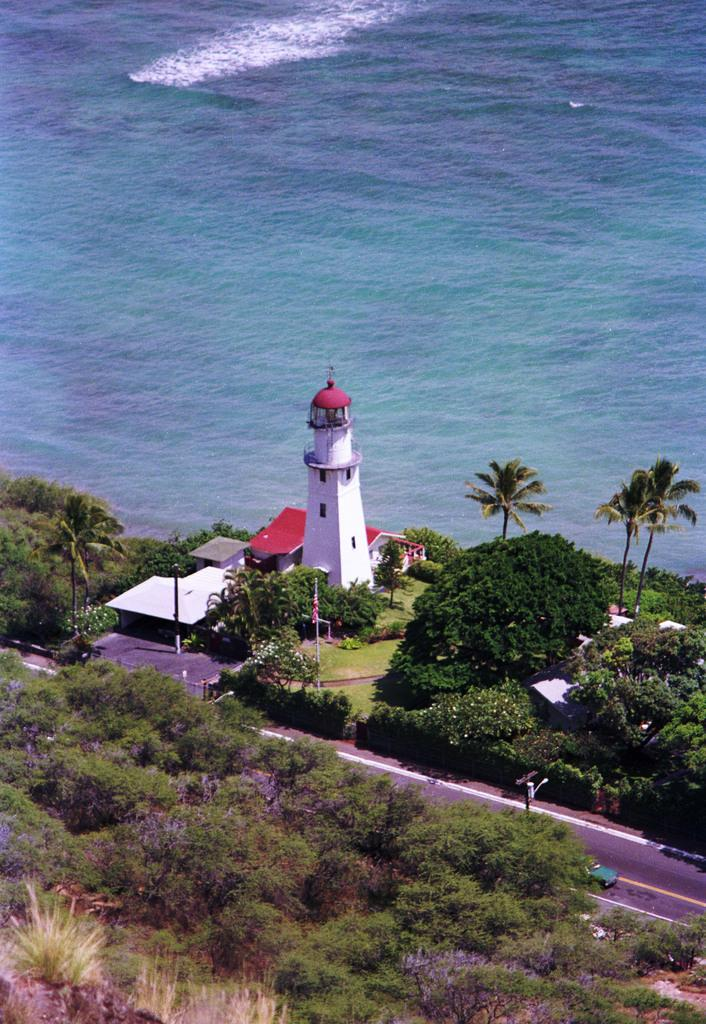What type of natural environment is present in the image? There are many trees in the area. What is the main structure visible in the image? There is a lighthouse in the image. Are there any man-made structures besides the lighthouse? Yes, there are buildings in the image. What can be seen in the distance behind the lighthouse and buildings? There is an ocean visible in the background. How many tents are set up for the camp in the image? There is no camp or tents present in the image. What direction is the lighthouse facing in the image? The image does not provide information about the direction the lighthouse is facing. 